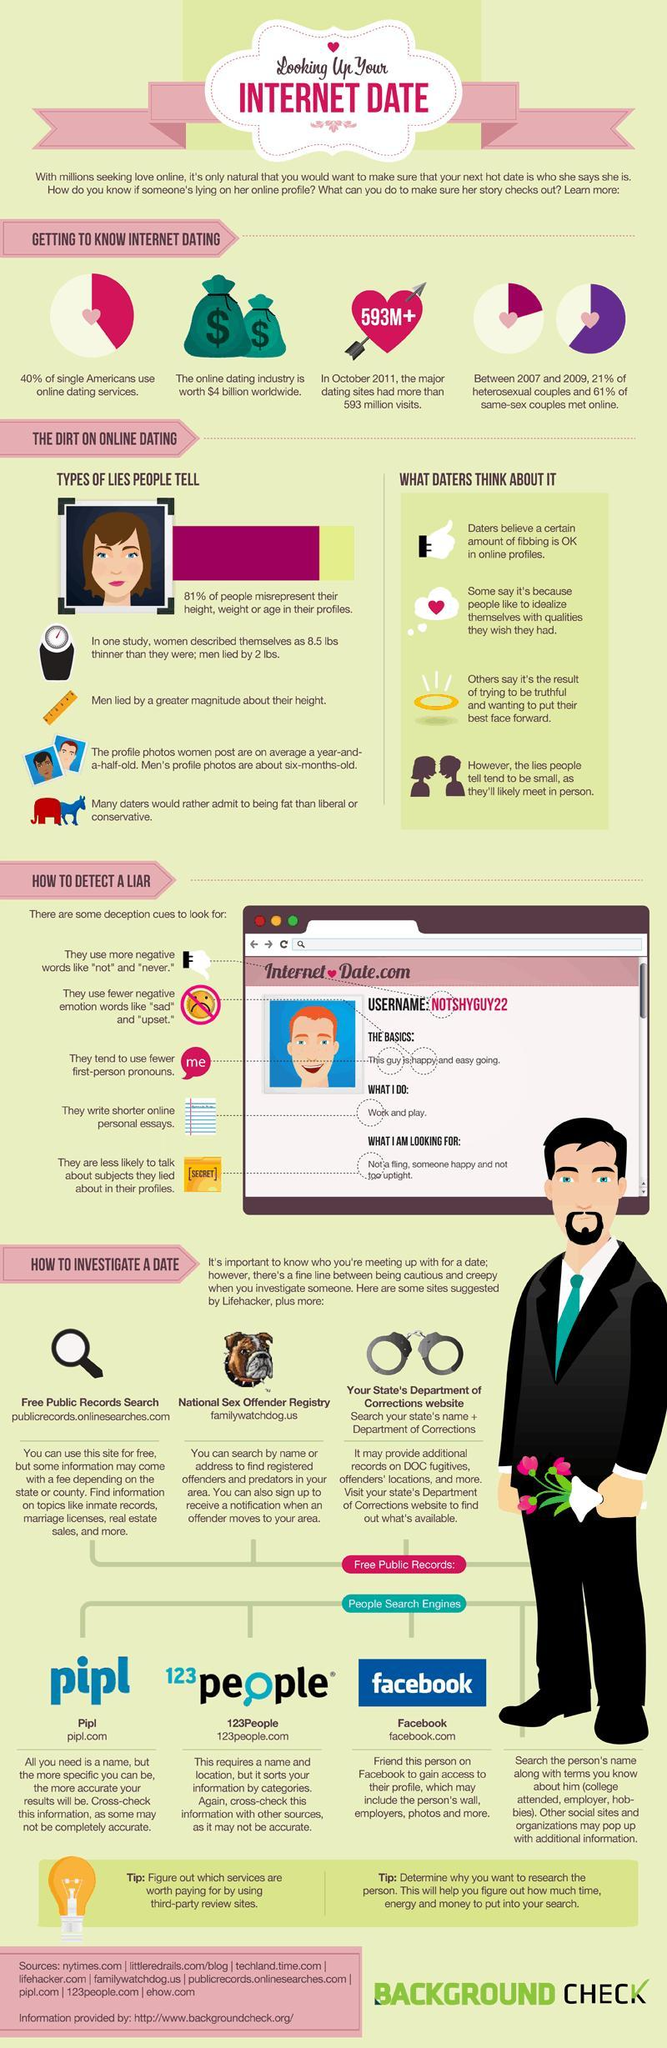How many sources are listed at the bottom?
Answer the question with a short phrase. 9 What percent of single Americans do not use online dating services? 60% 